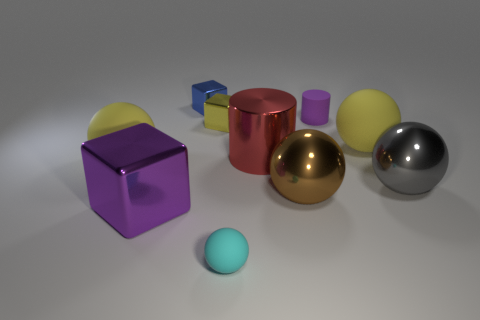Subtract all large gray balls. How many balls are left? 4 Subtract all gray spheres. How many spheres are left? 4 Subtract all green balls. Subtract all brown cylinders. How many balls are left? 5 Subtract all blocks. How many objects are left? 7 Add 4 yellow metal things. How many yellow metal things are left? 5 Add 5 big purple objects. How many big purple objects exist? 6 Subtract 0 gray cubes. How many objects are left? 10 Subtract all tiny purple rubber cylinders. Subtract all gray metal spheres. How many objects are left? 8 